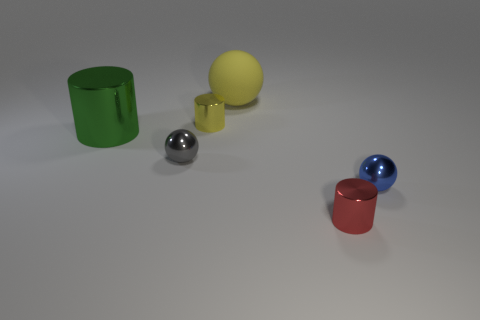Are there fewer yellow objects than tiny blue metal balls?
Provide a short and direct response. No. Are there any balls that are right of the tiny gray object to the left of the small thing that is on the right side of the red shiny cylinder?
Provide a short and direct response. Yes. There is a big object that is left of the matte ball; is its shape the same as the tiny gray thing?
Provide a succinct answer. No. Is the number of shiny spheres in front of the small red metal cylinder greater than the number of big cylinders?
Provide a short and direct response. No. Is the color of the cylinder to the right of the yellow sphere the same as the matte sphere?
Your answer should be compact. No. Is there anything else of the same color as the big sphere?
Provide a short and direct response. Yes. What color is the tiny cylinder behind the small metal thing on the right side of the small cylinder that is in front of the large shiny cylinder?
Provide a succinct answer. Yellow. Does the yellow metal thing have the same size as the red shiny cylinder?
Keep it short and to the point. Yes. What number of gray things have the same size as the blue metal thing?
Your response must be concise. 1. There is a shiny thing that is the same color as the large rubber object; what is its shape?
Your answer should be very brief. Cylinder. 